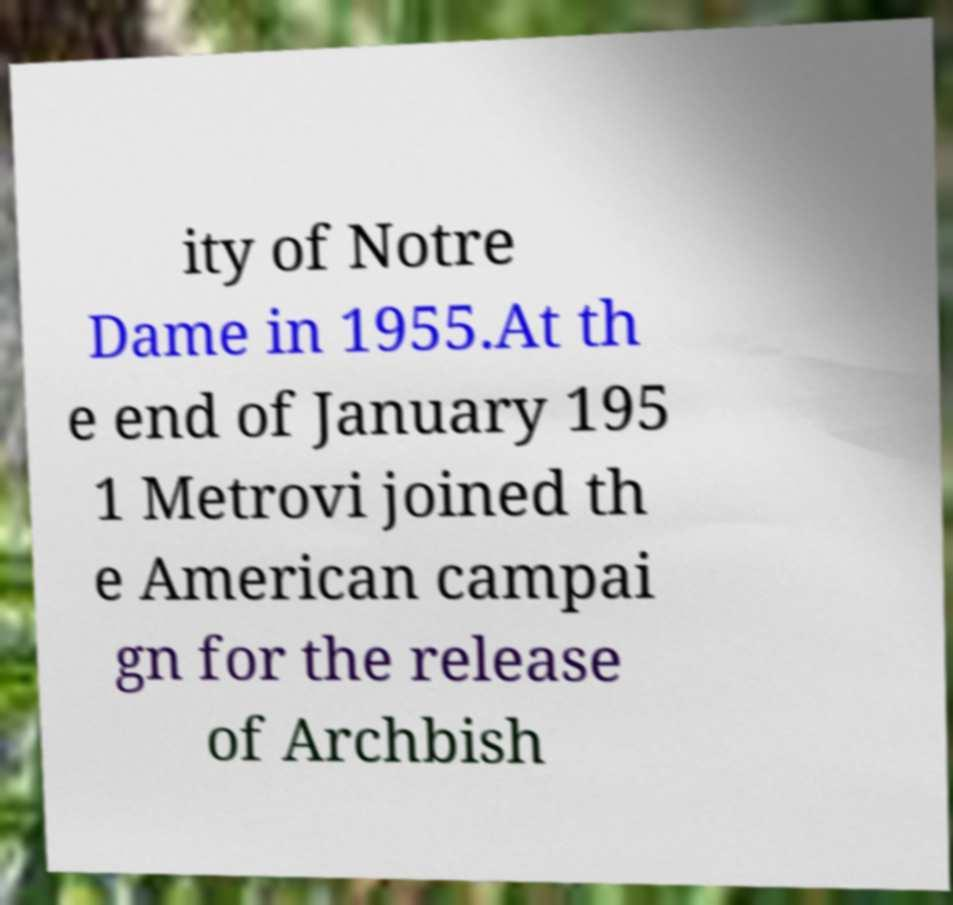There's text embedded in this image that I need extracted. Can you transcribe it verbatim? ity of Notre Dame in 1955.At th e end of January 195 1 Metrovi joined th e American campai gn for the release of Archbish 